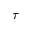<formula> <loc_0><loc_0><loc_500><loc_500>\tau</formula> 